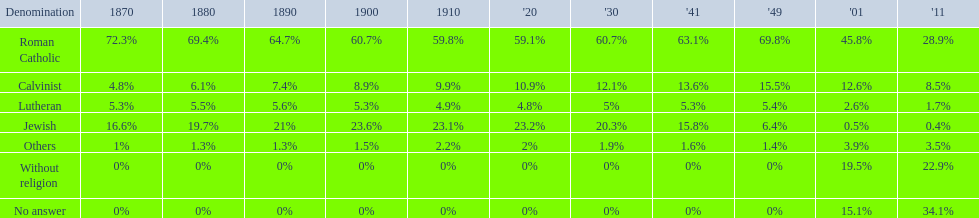What was the highest percentage of individuals identifying as calvinist? 15.5%. 